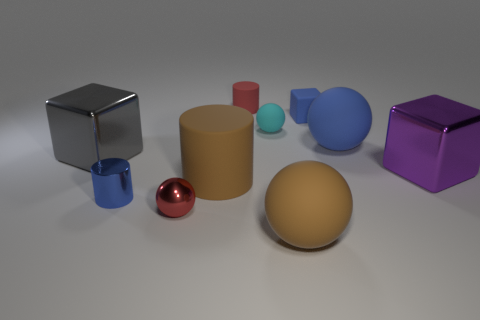Subtract all metal cubes. How many cubes are left? 1 Subtract 2 balls. How many balls are left? 2 Subtract all red balls. How many balls are left? 3 Subtract all red cylinders. How many blue spheres are left? 1 Subtract all cylinders. How many objects are left? 7 Subtract all metal cylinders. Subtract all big matte balls. How many objects are left? 7 Add 4 purple blocks. How many purple blocks are left? 5 Add 6 big matte things. How many big matte things exist? 9 Subtract 1 purple blocks. How many objects are left? 9 Subtract all blue spheres. Subtract all red cylinders. How many spheres are left? 3 